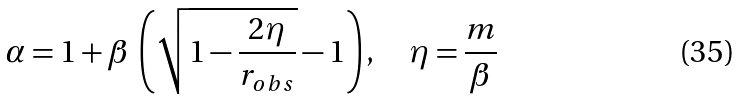<formula> <loc_0><loc_0><loc_500><loc_500>\alpha = 1 + \beta \, \left ( \sqrt { 1 - \frac { 2 \eta } { r _ { o b s } } } - 1 \right ) , \quad \eta = \frac { m } { \beta }</formula> 